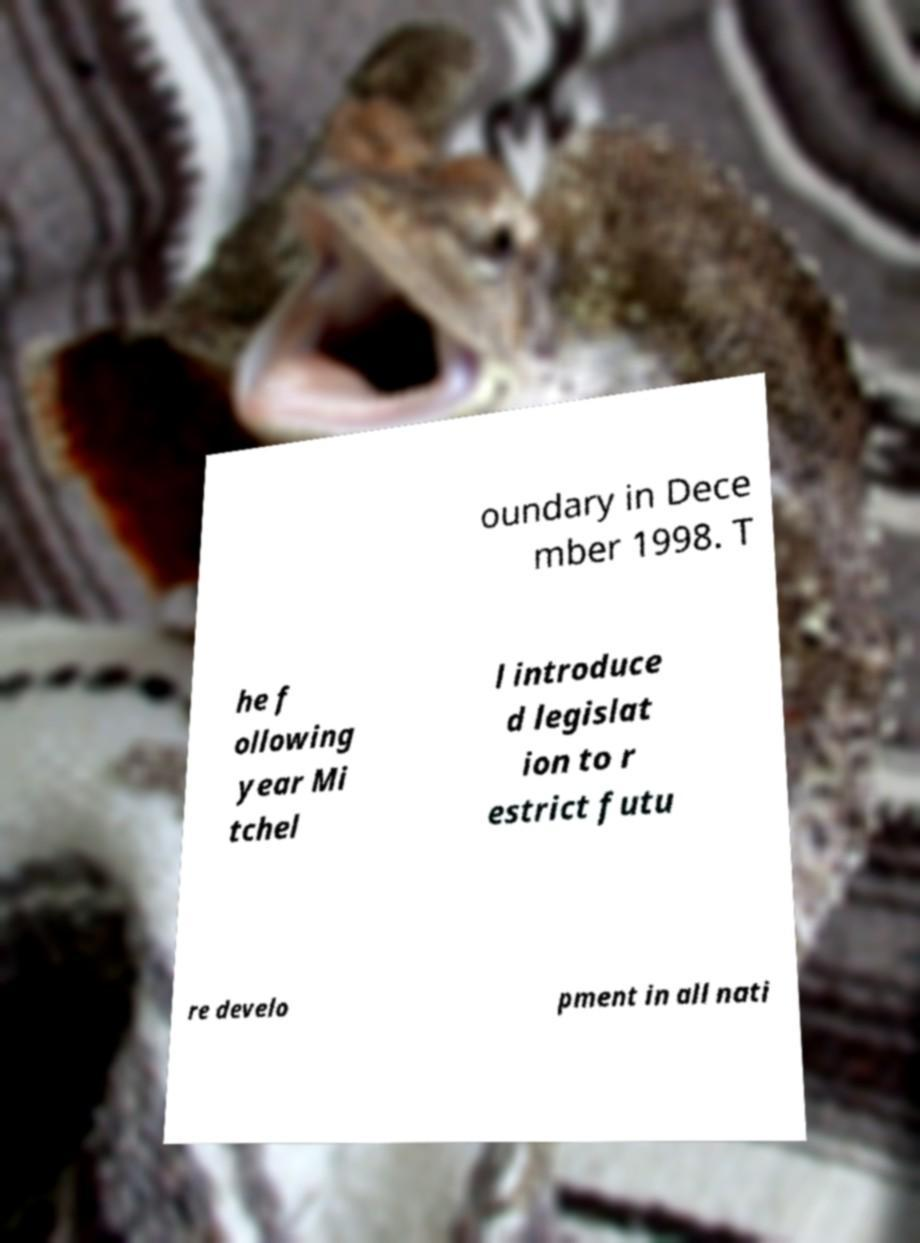Could you assist in decoding the text presented in this image and type it out clearly? oundary in Dece mber 1998. T he f ollowing year Mi tchel l introduce d legislat ion to r estrict futu re develo pment in all nati 